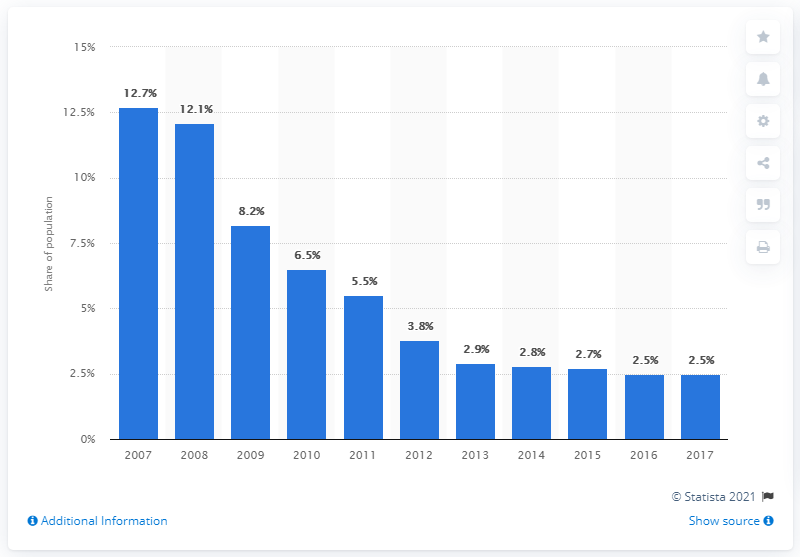List a handful of essential elements in this visual. The poverty headcount ratio at national poverty lines in Kazakhstan in 2017 was 2.5. 